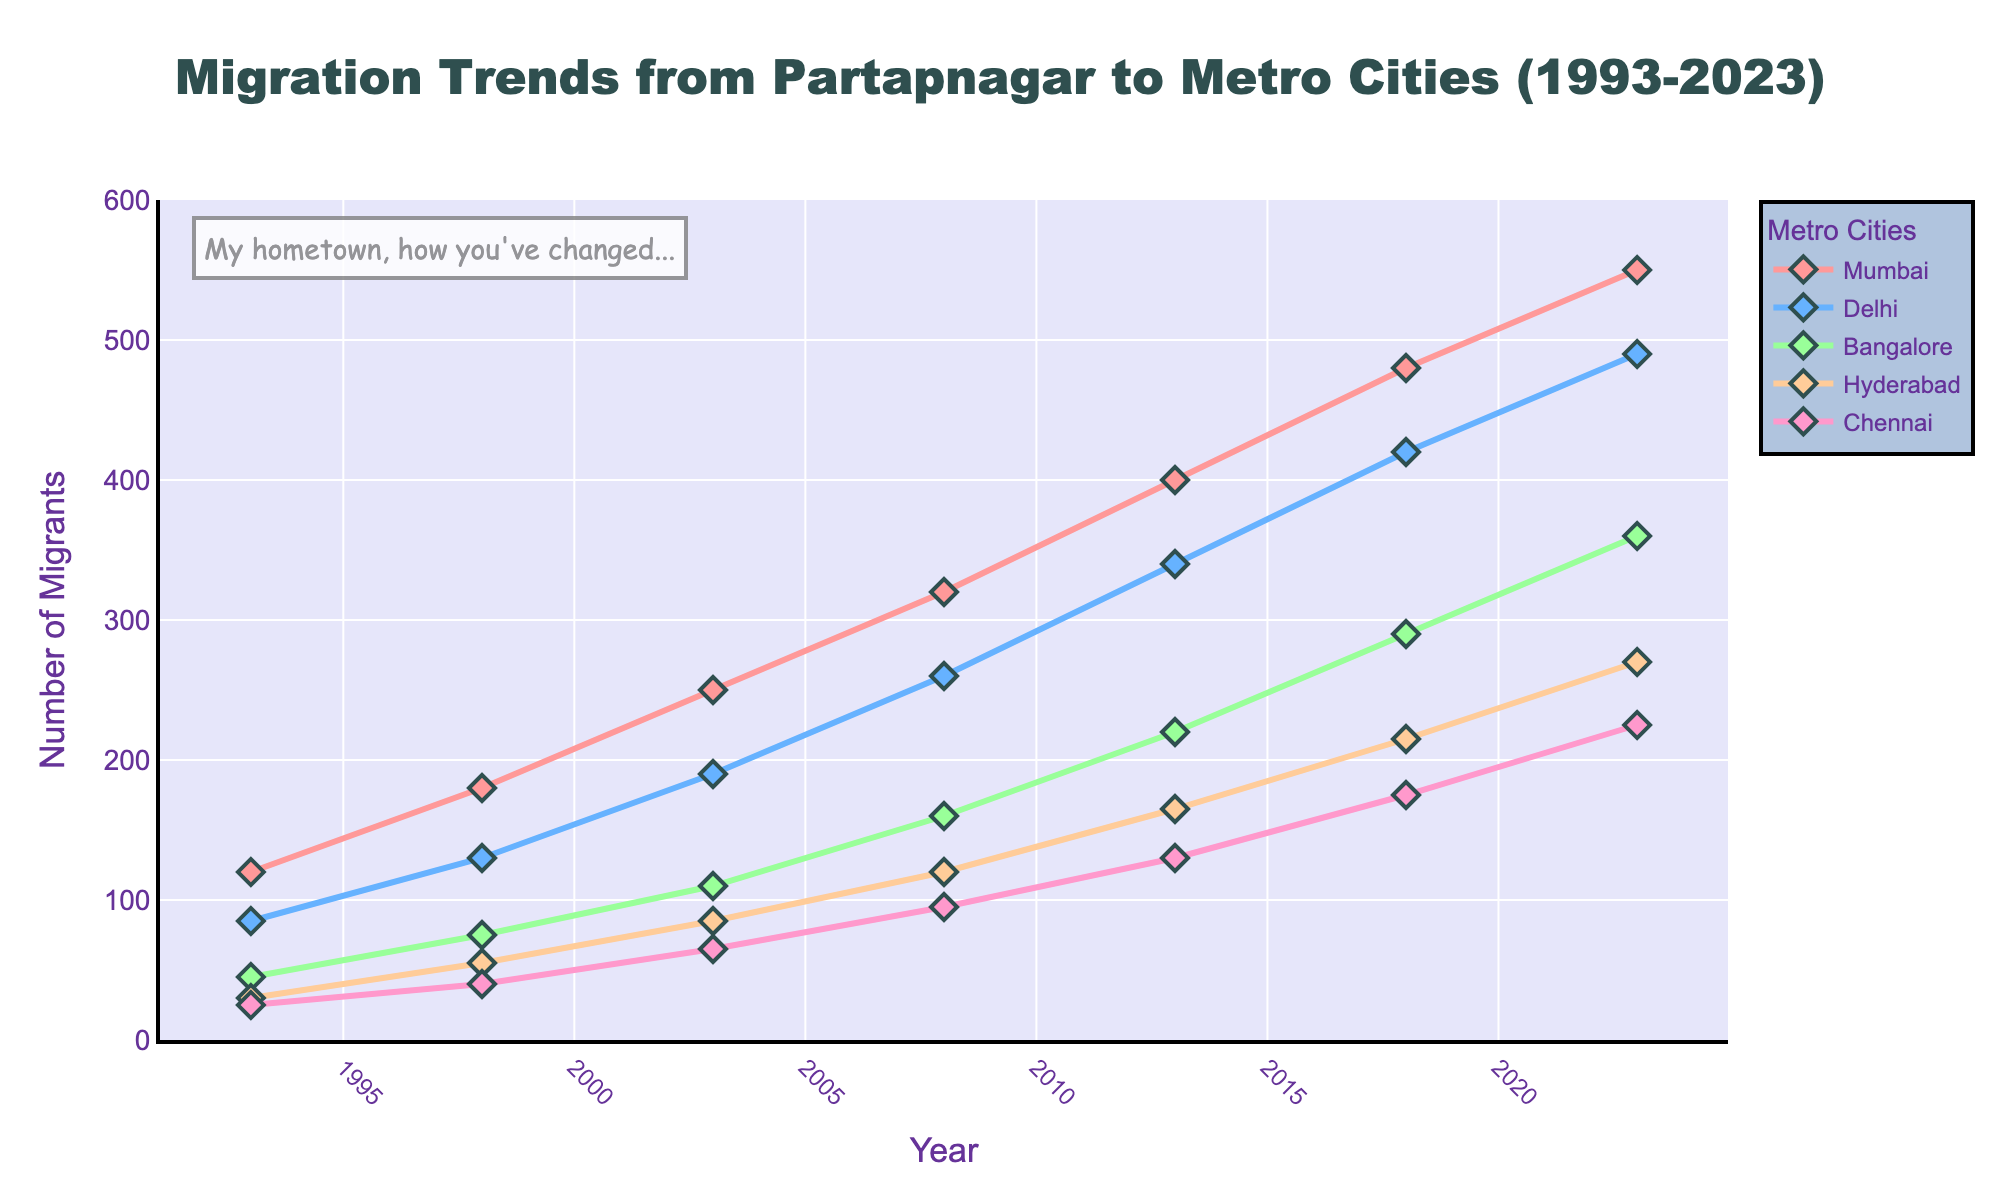What's the total number of migrants to all cities in 2023? To find the total number of migrants to all cities in 2023, sum up the values for Mumbai, Delhi, Bangalore, Hyderabad, and Chennai in the year 2023. These values are 550, 490, 360, 270, and 225, respectively. Therefore, the sum is 550 + 490 + 360 + 270 + 225 = 1895.
Answer: 1895 Which city experienced the highest increase in migrants from 1993 to 2023? Examine the figures for each city in 1993 and compare them to the figures in 2023. The increases are: Mumbai: 550-120=430, Delhi: 490-85=405, Bangalore: 360-45=315, Hyderabad: 270-30=240, Chennai: 225-25=200. Mumbai has the highest increase of 430.
Answer: Mumbai Which city had more migrants in 2003, Delhi or Hyderabad? Look at the values for Delhi and Hyderabad in 2003. Delhi had 190 migrants, and Hyderabad had 85 migrants. Comparing these two, Delhi had more migrants than Hyderabad.
Answer: Delhi What's the average number of migrants to Bangalore over the entire period? To find the average number of migrants to Bangalore, sum up the values for each year and divide by the number of years (7). The values are 45, 75, 110, 160, 220, 290, and 360. Sum these values: 45 + 75 + 110 + 160 + 220 + 290 + 360 = 1260. Divide the sum by 7: 1260/7 ≈ 180.
Answer: 180 In which year did the number of migrants to Chennai first exceed 100? Look at the values for Chennai for each year and find the first year when the value exceeds 100. The values are 25, 40, 65, 95, 130, 175, and 225. The first value exceeding 100 is 130 in the year 2013.
Answer: 2013 Comparing Mumbai and Bangalore, which city had a higher number of migrants in 2018? Look at the values for Mumbai and Bangalore in 2018. Mumbai had 480 migrants, and Bangalore had 290 migrants. Comparing these two, Mumbai had a higher number of migrants.
Answer: Mumbai What's the difference in the number of migrants to Hyderabad between 1998 and 2018? To find the difference, subtract the value for Hyderabad in 1998 from the value in 2018. These values are 55 and 215, respectively. Therefore, the difference is 215 - 55 = 160.
Answer: 160 Which city has the steepest upward trend in migration from 1993 to 2023? The steepest upward trend corresponds to the city with the largest increase in migrants over the period. Review the differences: Mumbai: 550-120=430, Delhi: 490-85=405, Bangalore: 360-45=315, Hyderabad: 270-30=240, Chennai: 225-25=200. Mumbai has the steepest upward trend with an increase of 430.
Answer: Mumbai How many total migrants moved to all cities combined in 2008? Sum the number of migrants to each city in 2008. The values are Mumbai: 320, Delhi: 260, Bangalore: 160, Hyderabad: 120, Chennai: 95. Therefore, the total is 320 + 260 + 160 + 120 + 95 = 955.
Answer: 955 